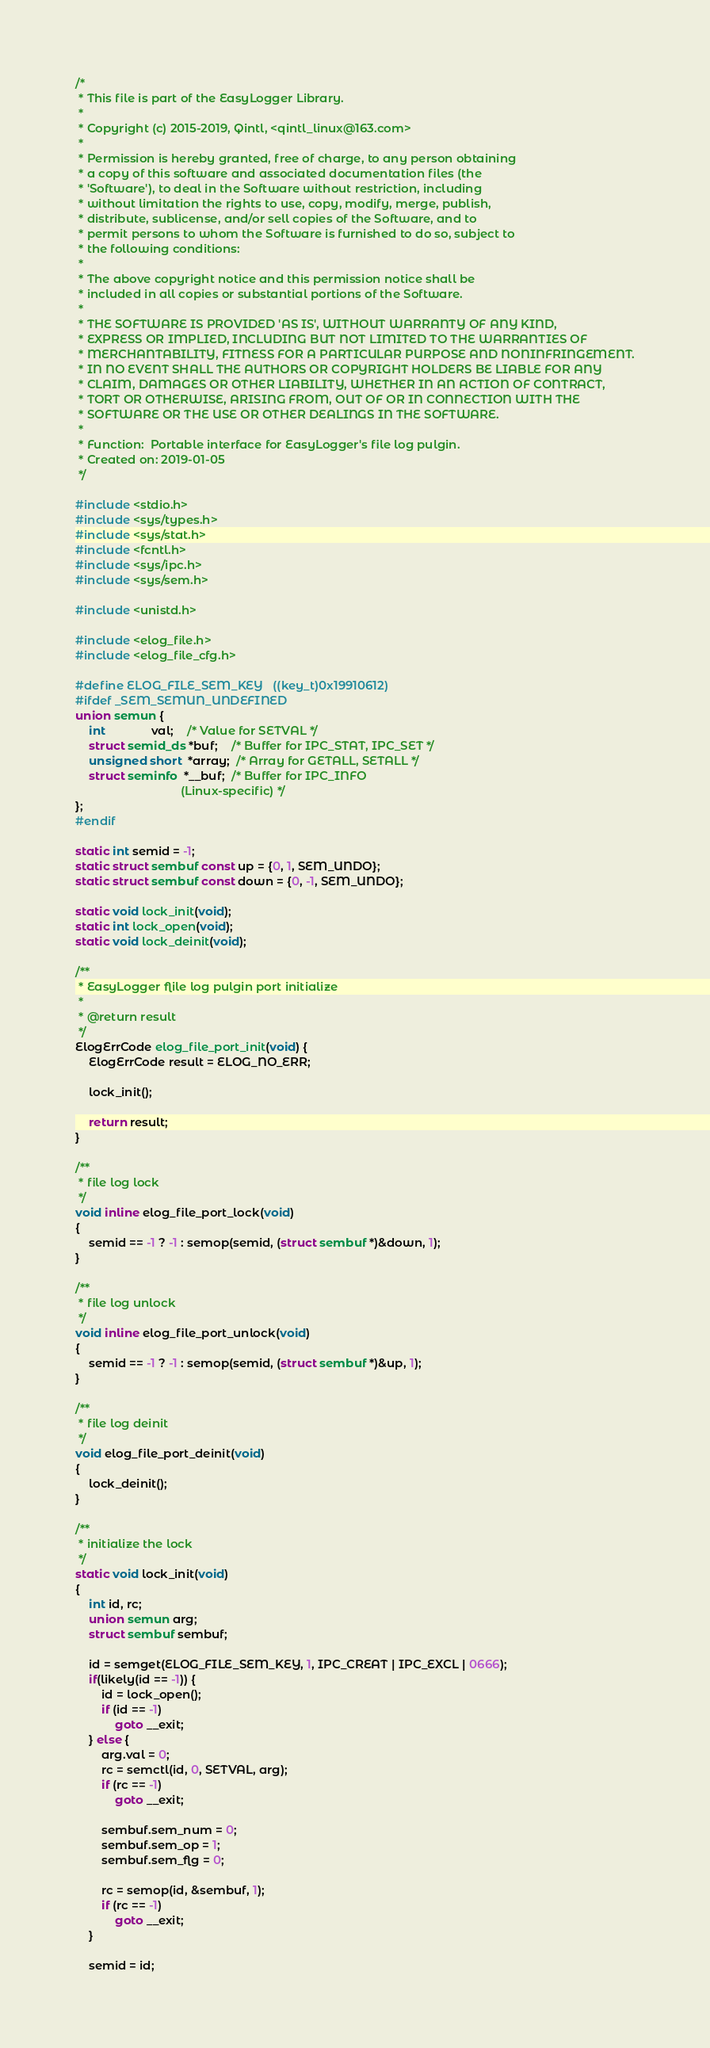<code> <loc_0><loc_0><loc_500><loc_500><_C_>/*
 * This file is part of the EasyLogger Library.
 *
 * Copyright (c) 2015-2019, Qintl, <qintl_linux@163.com>
 *
 * Permission is hereby granted, free of charge, to any person obtaining
 * a copy of this software and associated documentation files (the
 * 'Software'), to deal in the Software without restriction, including
 * without limitation the rights to use, copy, modify, merge, publish,
 * distribute, sublicense, and/or sell copies of the Software, and to
 * permit persons to whom the Software is furnished to do so, subject to
 * the following conditions:
 *
 * The above copyright notice and this permission notice shall be
 * included in all copies or substantial portions of the Software.
 *
 * THE SOFTWARE IS PROVIDED 'AS IS', WITHOUT WARRANTY OF ANY KIND,
 * EXPRESS OR IMPLIED, INCLUDING BUT NOT LIMITED TO THE WARRANTIES OF
 * MERCHANTABILITY, FITNESS FOR A PARTICULAR PURPOSE AND NONINFRINGEMENT.
 * IN NO EVENT SHALL THE AUTHORS OR COPYRIGHT HOLDERS BE LIABLE FOR ANY
 * CLAIM, DAMAGES OR OTHER LIABILITY, WHETHER IN AN ACTION OF CONTRACT,
 * TORT OR OTHERWISE, ARISING FROM, OUT OF OR IN CONNECTION WITH THE
 * SOFTWARE OR THE USE OR OTHER DEALINGS IN THE SOFTWARE.
 *
 * Function:  Portable interface for EasyLogger's file log pulgin.
 * Created on: 2019-01-05
 */

#include <stdio.h>
#include <sys/types.h>
#include <sys/stat.h>
#include <fcntl.h>
#include <sys/ipc.h>
#include <sys/sem.h>

#include <unistd.h>

#include <elog_file.h>
#include <elog_file_cfg.h>

#define ELOG_FILE_SEM_KEY   ((key_t)0x19910612)
#ifdef _SEM_SEMUN_UNDEFINED
union semun {
    int              val;    /* Value for SETVAL */
    struct semid_ds *buf;    /* Buffer for IPC_STAT, IPC_SET */
    unsigned short  *array;  /* Array for GETALL, SETALL */
    struct seminfo  *__buf;  /* Buffer for IPC_INFO
                                (Linux-specific) */
};
#endif

static int semid = -1;
static struct sembuf const up = {0, 1, SEM_UNDO};
static struct sembuf const down = {0, -1, SEM_UNDO};

static void lock_init(void);
static int lock_open(void);
static void lock_deinit(void);

/**
 * EasyLogger flile log pulgin port initialize
 *
 * @return result
 */
ElogErrCode elog_file_port_init(void) {
    ElogErrCode result = ELOG_NO_ERR;

    lock_init();

    return result;
}

/**
 * file log lock
 */
void inline elog_file_port_lock(void)
{
    semid == -1 ? -1 : semop(semid, (struct sembuf *)&down, 1);
}

/**
 * file log unlock
 */
void inline elog_file_port_unlock(void)
{
    semid == -1 ? -1 : semop(semid, (struct sembuf *)&up, 1);
}

/**
 * file log deinit
 */
void elog_file_port_deinit(void)
{
    lock_deinit();
}

/**
 * initialize the lock 
 */
static void lock_init(void)
{
    int id, rc;
    union semun arg;
    struct sembuf sembuf;

    id = semget(ELOG_FILE_SEM_KEY, 1, IPC_CREAT | IPC_EXCL | 0666);
    if(likely(id == -1)) {
        id = lock_open();
        if (id == -1)
            goto __exit;
    } else {
        arg.val = 0;
        rc = semctl(id, 0, SETVAL, arg);
        if (rc == -1)
            goto __exit;

        sembuf.sem_num = 0;
        sembuf.sem_op = 1;
        sembuf.sem_flg = 0;

        rc = semop(id, &sembuf, 1);
        if (rc == -1)
            goto __exit;
    }

    semid = id;</code> 